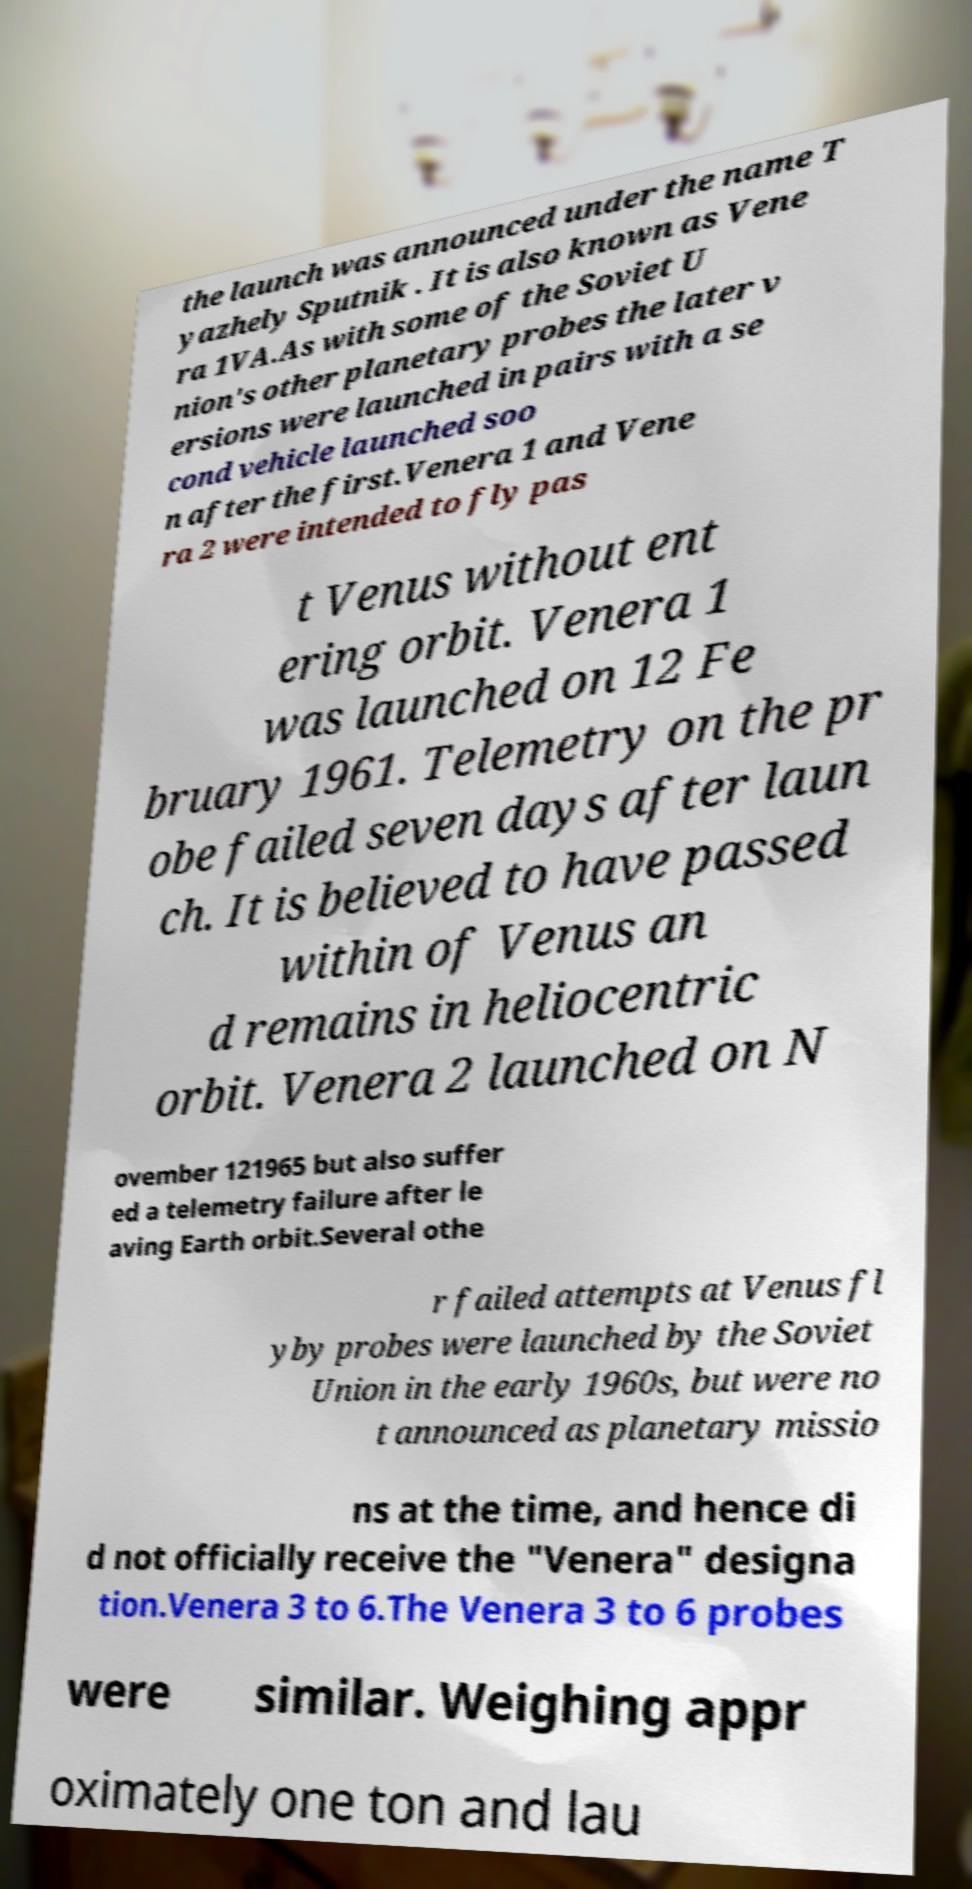What messages or text are displayed in this image? I need them in a readable, typed format. the launch was announced under the name T yazhely Sputnik . It is also known as Vene ra 1VA.As with some of the Soviet U nion's other planetary probes the later v ersions were launched in pairs with a se cond vehicle launched soo n after the first.Venera 1 and Vene ra 2 were intended to fly pas t Venus without ent ering orbit. Venera 1 was launched on 12 Fe bruary 1961. Telemetry on the pr obe failed seven days after laun ch. It is believed to have passed within of Venus an d remains in heliocentric orbit. Venera 2 launched on N ovember 121965 but also suffer ed a telemetry failure after le aving Earth orbit.Several othe r failed attempts at Venus fl yby probes were launched by the Soviet Union in the early 1960s, but were no t announced as planetary missio ns at the time, and hence di d not officially receive the "Venera" designa tion.Venera 3 to 6.The Venera 3 to 6 probes were similar. Weighing appr oximately one ton and lau 